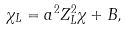Convert formula to latex. <formula><loc_0><loc_0><loc_500><loc_500>\chi _ { L } = a ^ { 2 } Z _ { L } ^ { 2 } \chi + B ,</formula> 